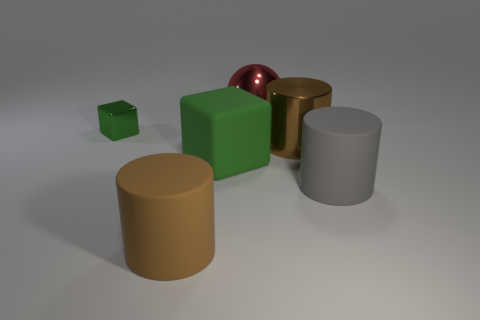Add 2 brown rubber things. How many objects exist? 8 Subtract all gray cylinders. How many cylinders are left? 2 Subtract all big gray matte cylinders. How many cylinders are left? 2 Subtract 1 spheres. How many spheres are left? 0 Subtract all cubes. How many objects are left? 4 Subtract all purple spheres. Subtract all yellow cubes. How many spheres are left? 1 Subtract all red spheres. How many blue cylinders are left? 0 Add 2 rubber cylinders. How many rubber cylinders exist? 4 Subtract 2 brown cylinders. How many objects are left? 4 Subtract all metal cubes. Subtract all big matte cubes. How many objects are left? 4 